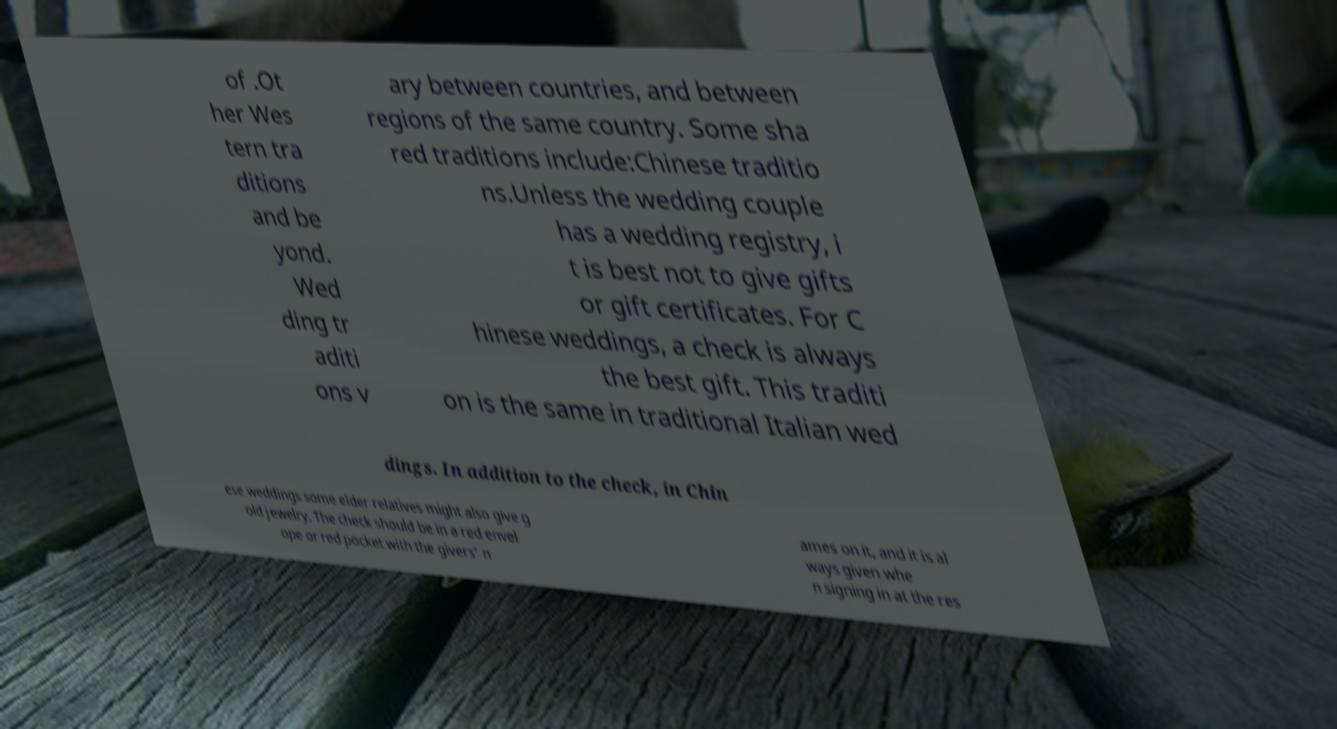Please identify and transcribe the text found in this image. of .Ot her Wes tern tra ditions and be yond. Wed ding tr aditi ons v ary between countries, and between regions of the same country. Some sha red traditions include:Chinese traditio ns.Unless the wedding couple has a wedding registry, i t is best not to give gifts or gift certificates. For C hinese weddings, a check is always the best gift. This traditi on is the same in traditional Italian wed dings. In addition to the check, in Chin ese weddings some elder relatives might also give g old jewelry. The check should be in a red envel ope or red pocket with the givers' n ames on it, and it is al ways given whe n signing in at the res 